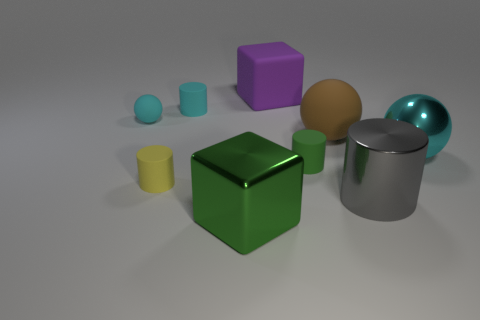What material is the cylinder behind the brown matte object?
Ensure brevity in your answer.  Rubber. What is the shape of the small rubber thing that is the same color as the large shiny block?
Give a very brief answer. Cylinder. What color is the other matte object that is the same shape as the big brown matte thing?
Ensure brevity in your answer.  Cyan. Do the block that is in front of the large cylinder and the tiny yellow cylinder have the same material?
Keep it short and to the point. No. How many tiny rubber cylinders are there?
Provide a short and direct response. 3. What is the size of the cube in front of the purple rubber cube?
Provide a succinct answer. Large. Is the size of the purple object the same as the yellow rubber thing?
Provide a short and direct response. No. What number of things are small blue matte cylinders or blocks in front of the gray cylinder?
Your answer should be compact. 1. What is the material of the small green cylinder?
Offer a terse response. Rubber. Is there any other thing that has the same color as the large cylinder?
Give a very brief answer. No. 